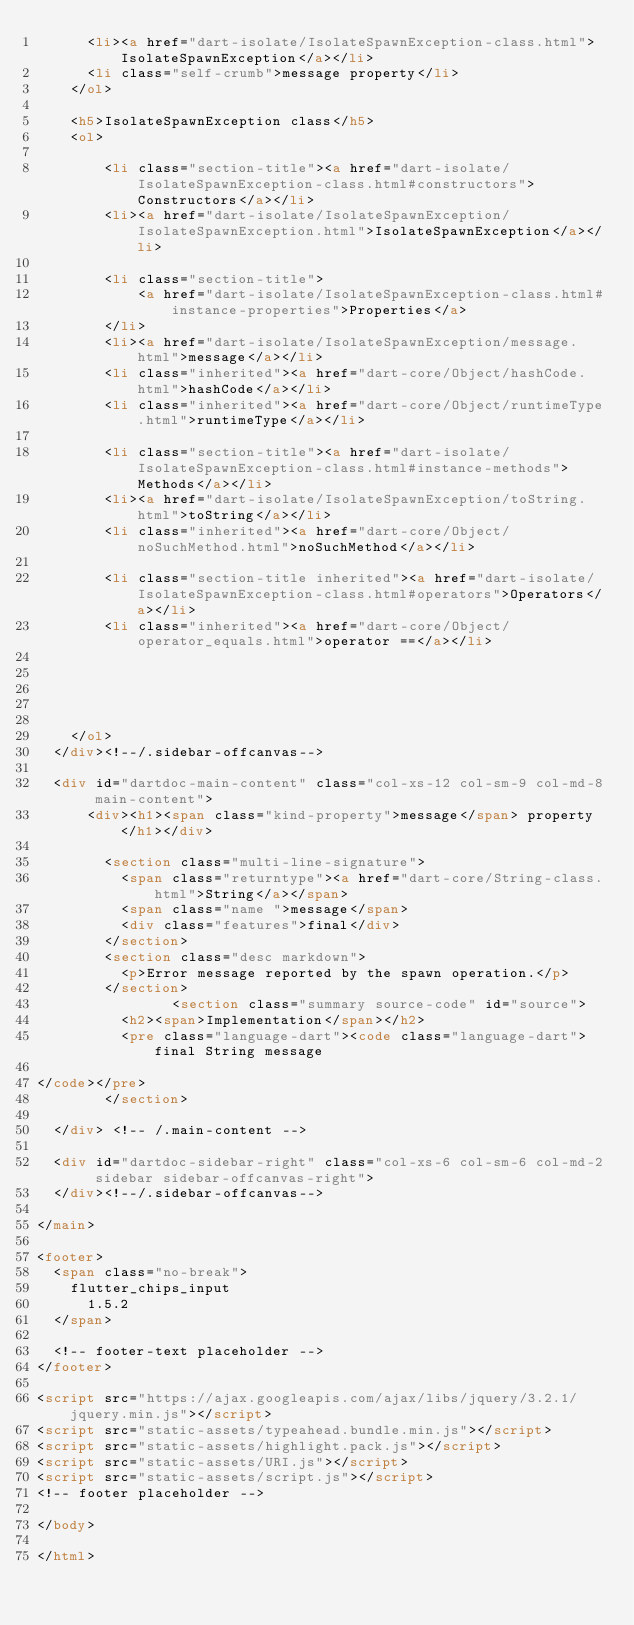<code> <loc_0><loc_0><loc_500><loc_500><_HTML_>      <li><a href="dart-isolate/IsolateSpawnException-class.html">IsolateSpawnException</a></li>
      <li class="self-crumb">message property</li>
    </ol>
    
    <h5>IsolateSpawnException class</h5>
    <ol>
    
        <li class="section-title"><a href="dart-isolate/IsolateSpawnException-class.html#constructors">Constructors</a></li>
        <li><a href="dart-isolate/IsolateSpawnException/IsolateSpawnException.html">IsolateSpawnException</a></li>
    
        <li class="section-title">
            <a href="dart-isolate/IsolateSpawnException-class.html#instance-properties">Properties</a>
        </li>
        <li><a href="dart-isolate/IsolateSpawnException/message.html">message</a></li>
        <li class="inherited"><a href="dart-core/Object/hashCode.html">hashCode</a></li>
        <li class="inherited"><a href="dart-core/Object/runtimeType.html">runtimeType</a></li>
    
        <li class="section-title"><a href="dart-isolate/IsolateSpawnException-class.html#instance-methods">Methods</a></li>
        <li><a href="dart-isolate/IsolateSpawnException/toString.html">toString</a></li>
        <li class="inherited"><a href="dart-core/Object/noSuchMethod.html">noSuchMethod</a></li>
    
        <li class="section-title inherited"><a href="dart-isolate/IsolateSpawnException-class.html#operators">Operators</a></li>
        <li class="inherited"><a href="dart-core/Object/operator_equals.html">operator ==</a></li>
    
    
    
    
    
    </ol>
  </div><!--/.sidebar-offcanvas-->

  <div id="dartdoc-main-content" class="col-xs-12 col-sm-9 col-md-8 main-content">
      <div><h1><span class="kind-property">message</span> property</h1></div>

        <section class="multi-line-signature">
          <span class="returntype"><a href="dart-core/String-class.html">String</a></span>
          <span class="name ">message</span>
          <div class="features">final</div>
        </section>
        <section class="desc markdown">
          <p>Error message reported by the spawn operation.</p>
        </section>
                <section class="summary source-code" id="source">
          <h2><span>Implementation</span></h2>
          <pre class="language-dart"><code class="language-dart">final String message

</code></pre>
        </section>

  </div> <!-- /.main-content -->

  <div id="dartdoc-sidebar-right" class="col-xs-6 col-sm-6 col-md-2 sidebar sidebar-offcanvas-right">
  </div><!--/.sidebar-offcanvas-->

</main>

<footer>
  <span class="no-break">
    flutter_chips_input
      1.5.2
  </span>

  <!-- footer-text placeholder -->
</footer>

<script src="https://ajax.googleapis.com/ajax/libs/jquery/3.2.1/jquery.min.js"></script>
<script src="static-assets/typeahead.bundle.min.js"></script>
<script src="static-assets/highlight.pack.js"></script>
<script src="static-assets/URI.js"></script>
<script src="static-assets/script.js"></script>
<!-- footer placeholder -->

</body>

</html>
</code> 